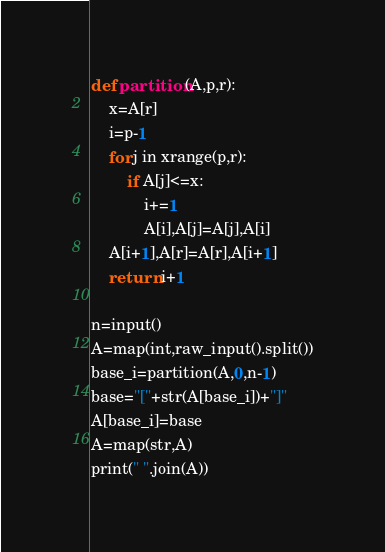Convert code to text. <code><loc_0><loc_0><loc_500><loc_500><_Python_>def partition(A,p,r):
    x=A[r]
    i=p-1
    for j in xrange(p,r):
        if A[j]<=x:
            i+=1
            A[i],A[j]=A[j],A[i]
    A[i+1],A[r]=A[r],A[i+1]
    return i+1

n=input()
A=map(int,raw_input().split())
base_i=partition(A,0,n-1)
base="["+str(A[base_i])+"]"
A[base_i]=base
A=map(str,A)
print(" ".join(A))</code> 